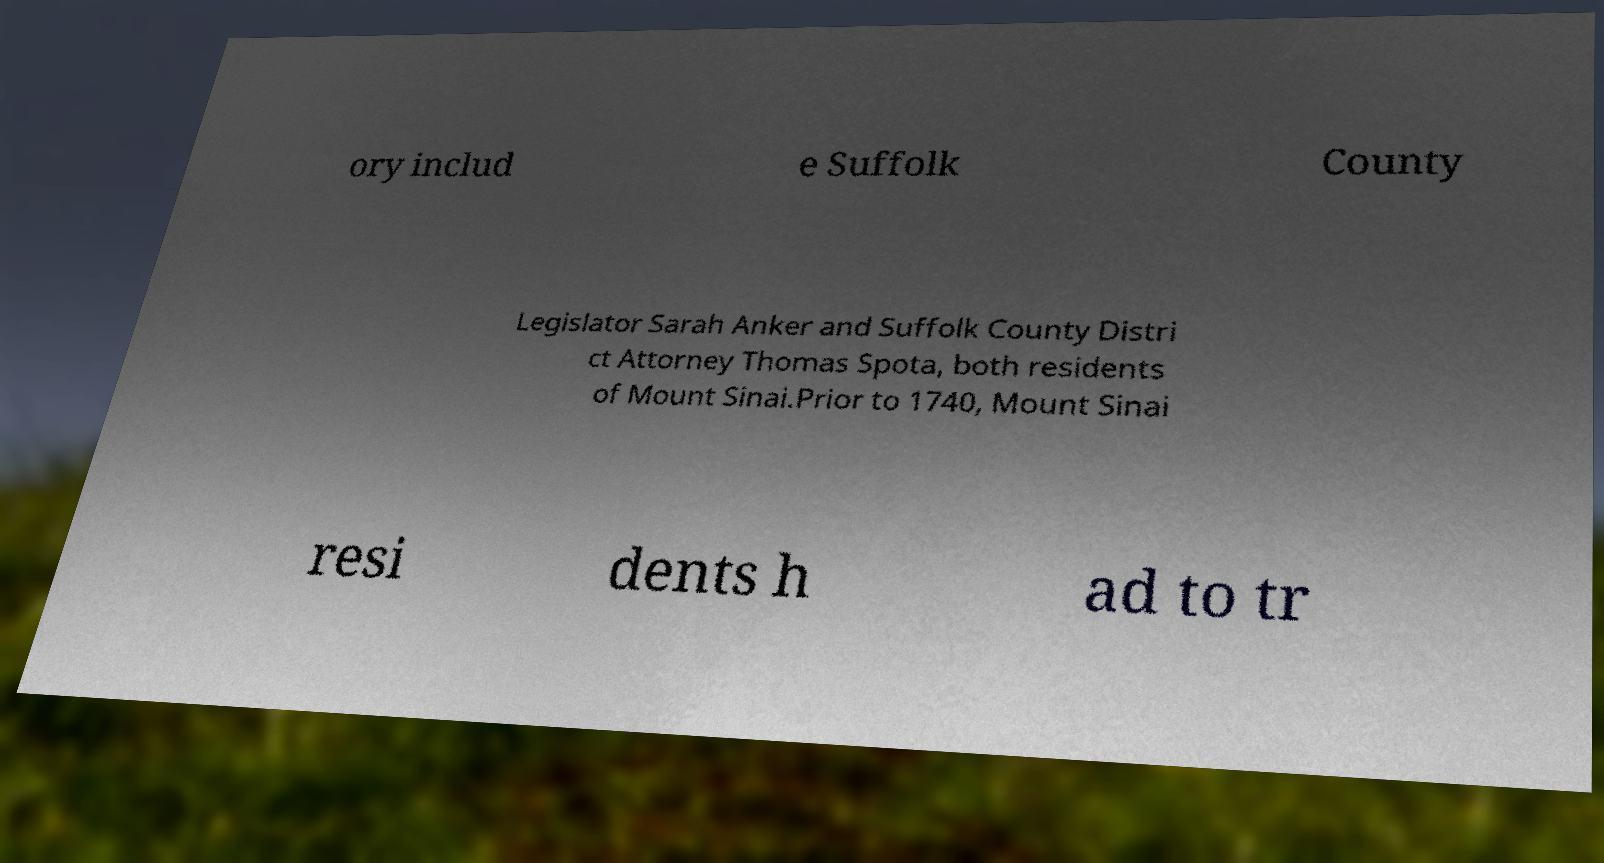Can you read and provide the text displayed in the image?This photo seems to have some interesting text. Can you extract and type it out for me? ory includ e Suffolk County Legislator Sarah Anker and Suffolk County Distri ct Attorney Thomas Spota, both residents of Mount Sinai.Prior to 1740, Mount Sinai resi dents h ad to tr 